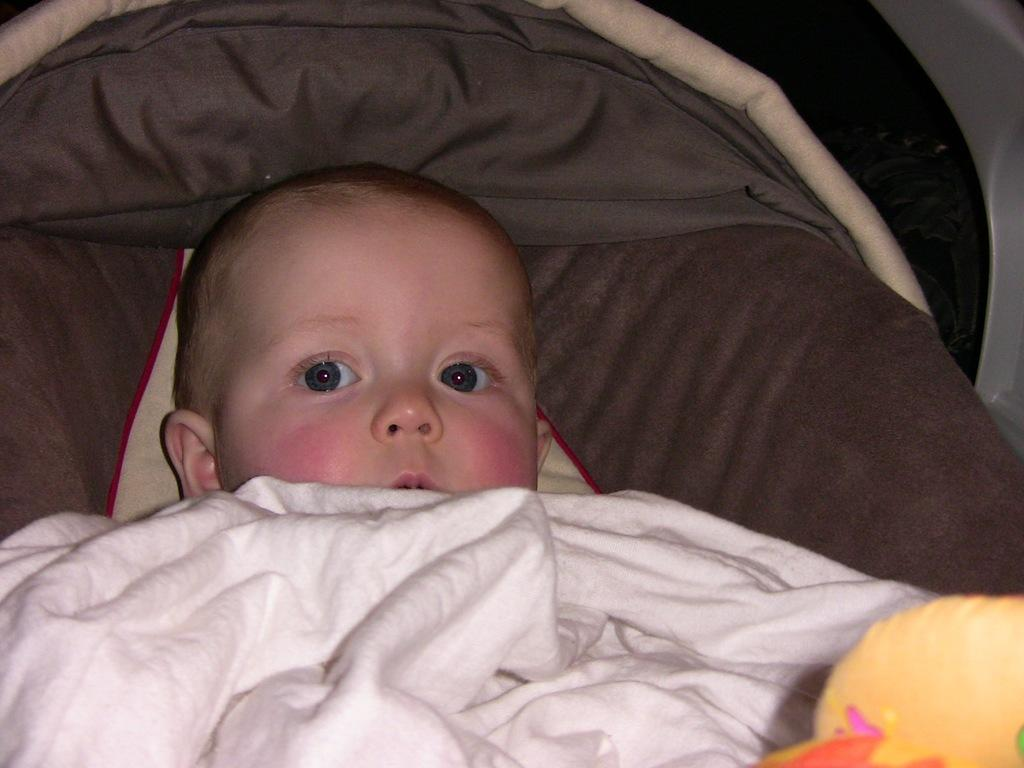What is the main subject of the image? There is a baby in the image. What is the color of the cloth in the image? There is a white cloth in the image. What is the color of the object next to the baby? There is a yellow-colored object in the image. What else can be seen in the image besides the baby, cloth, and yellow object? There are additional clothes visible in the image. What type of fruit is being held in a quiver by the baby in the image? There is no fruit or quiver present in the image; the baby is not holding any such items. 